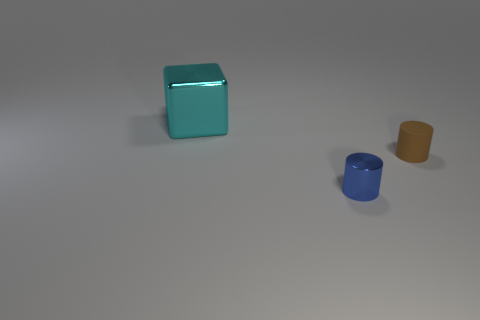Add 2 tiny brown matte objects. How many objects exist? 5 Subtract all cylinders. How many objects are left? 1 Add 2 brown spheres. How many brown spheres exist? 2 Subtract all blue cylinders. How many cylinders are left? 1 Subtract 0 cyan balls. How many objects are left? 3 Subtract 1 cylinders. How many cylinders are left? 1 Subtract all yellow cylinders. Subtract all gray cubes. How many cylinders are left? 2 Subtract all red cylinders. How many brown cubes are left? 0 Subtract all small spheres. Subtract all small blue objects. How many objects are left? 2 Add 3 small brown matte objects. How many small brown matte objects are left? 4 